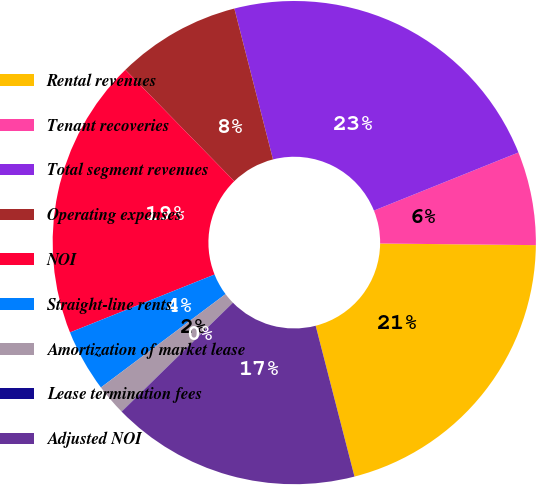Convert chart to OTSL. <chart><loc_0><loc_0><loc_500><loc_500><pie_chart><fcel>Rental revenues<fcel>Tenant recoveries<fcel>Total segment revenues<fcel>Operating expenses<fcel>NOI<fcel>Straight-line rents<fcel>Amortization of market lease<fcel>Lease termination fees<fcel>Adjusted NOI<nl><fcel>20.82%<fcel>6.25%<fcel>22.9%<fcel>8.33%<fcel>18.74%<fcel>4.17%<fcel>2.09%<fcel>0.01%<fcel>16.67%<nl></chart> 